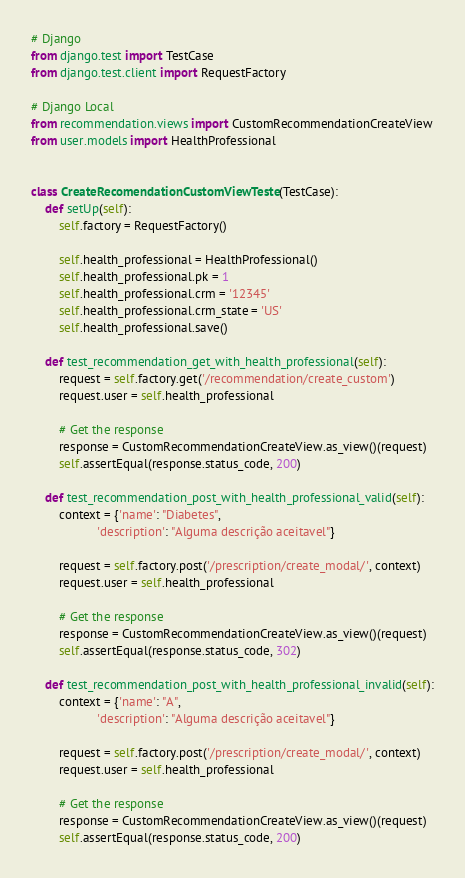Convert code to text. <code><loc_0><loc_0><loc_500><loc_500><_Python_># Django
from django.test import TestCase
from django.test.client import RequestFactory

# Django Local
from recommendation.views import CustomRecommendationCreateView
from user.models import HealthProfessional


class CreateRecomendationCustomViewTeste(TestCase):
    def setUp(self):
        self.factory = RequestFactory()

        self.health_professional = HealthProfessional()
        self.health_professional.pk = 1
        self.health_professional.crm = '12345'
        self.health_professional.crm_state = 'US'
        self.health_professional.save()

    def test_recommendation_get_with_health_professional(self):
        request = self.factory.get('/recommendation/create_custom')
        request.user = self.health_professional

        # Get the response
        response = CustomRecommendationCreateView.as_view()(request)
        self.assertEqual(response.status_code, 200)

    def test_recommendation_post_with_health_professional_valid(self):
        context = {'name': "Diabetes",
                   'description': "Alguma descrição aceitavel"}

        request = self.factory.post('/prescription/create_modal/', context)
        request.user = self.health_professional

        # Get the response
        response = CustomRecommendationCreateView.as_view()(request)
        self.assertEqual(response.status_code, 302)

    def test_recommendation_post_with_health_professional_invalid(self):
        context = {'name': "A",
                   'description': "Alguma descrição aceitavel"}

        request = self.factory.post('/prescription/create_modal/', context)
        request.user = self.health_professional

        # Get the response
        response = CustomRecommendationCreateView.as_view()(request)
        self.assertEqual(response.status_code, 200)
</code> 